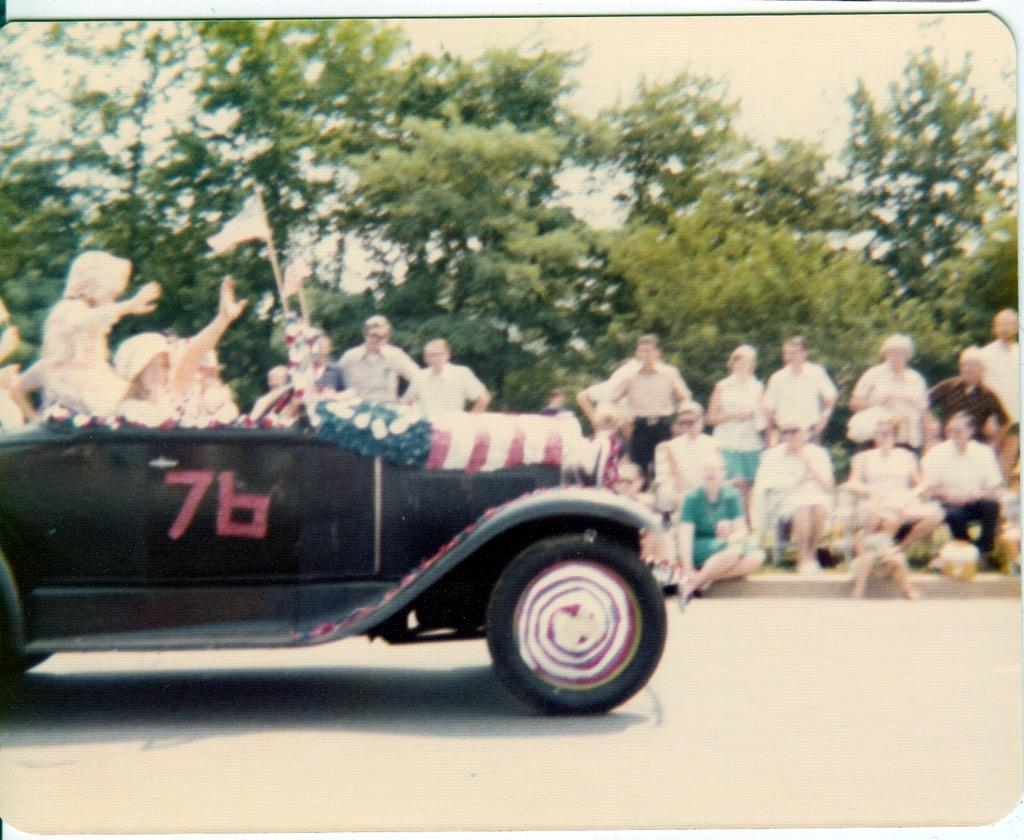What can be seen in the background of the image? There are trees in the background of the image. What are the people in the image doing? There are persons standing and sitting on a footpath, and some are sitting in a car. What is the purpose of the flag in the image? The flag's purpose is not specified in the image, but it could be for decoration or identification. What type of surface is visible in the image? There is a road in the image, which is a type of surface for vehicles and pedestrians. What type of stage can be seen in the image? There is: There is no stage present in the image; it features trees, people, a flag, and a road. What is the texture of the circle in the image? There is no circle present in the image, so it is not possible to describe its texture. 